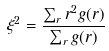<formula> <loc_0><loc_0><loc_500><loc_500>\xi ^ { 2 } = \frac { \sum _ { r } r ^ { 2 } g ( r ) } { \sum _ { r } g ( r ) }</formula> 